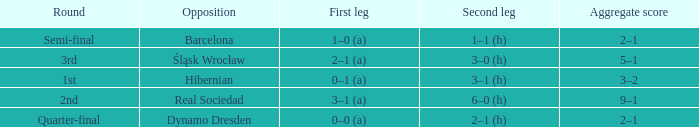What was the first leg score against Real Sociedad? 3–1 (a). 